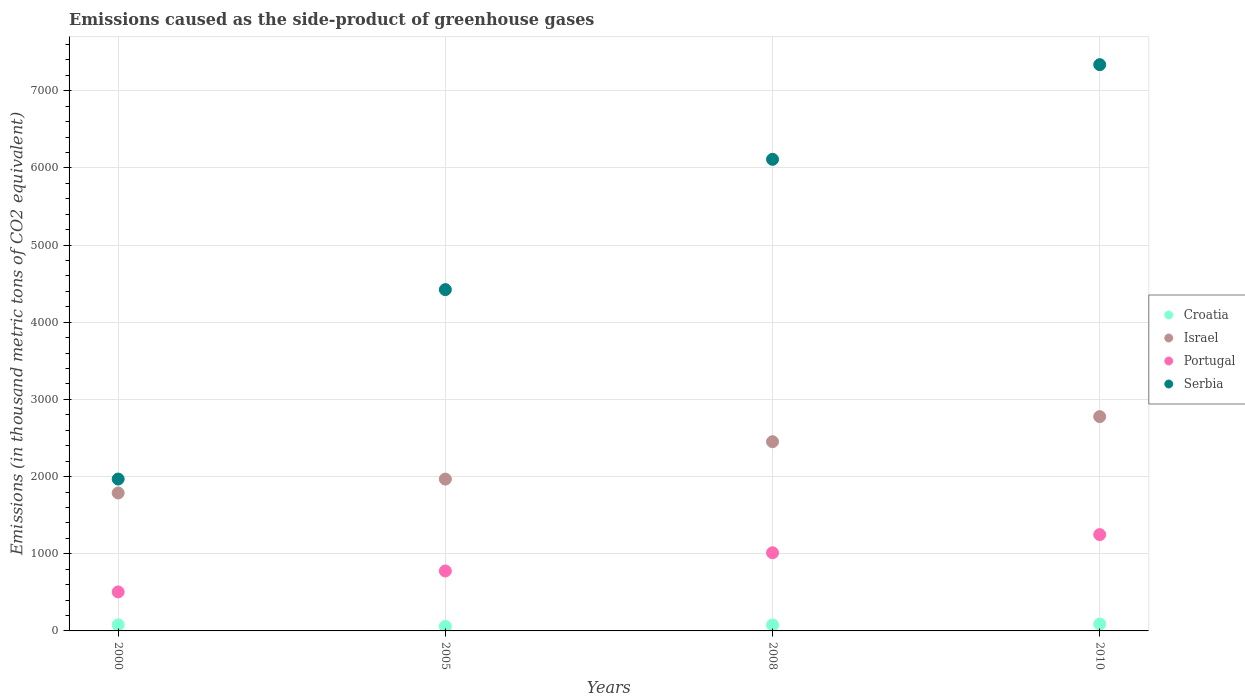How many different coloured dotlines are there?
Your answer should be compact. 4. What is the emissions caused as the side-product of greenhouse gases in Portugal in 2000?
Give a very brief answer. 505.3. Across all years, what is the maximum emissions caused as the side-product of greenhouse gases in Serbia?
Make the answer very short. 7338. Across all years, what is the minimum emissions caused as the side-product of greenhouse gases in Israel?
Your response must be concise. 1787.6. What is the total emissions caused as the side-product of greenhouse gases in Portugal in the graph?
Make the answer very short. 3542.9. What is the difference between the emissions caused as the side-product of greenhouse gases in Serbia in 2000 and that in 2005?
Provide a short and direct response. -2454.7. What is the difference between the emissions caused as the side-product of greenhouse gases in Portugal in 2000 and the emissions caused as the side-product of greenhouse gases in Serbia in 2008?
Your answer should be very brief. -5606. What is the average emissions caused as the side-product of greenhouse gases in Croatia per year?
Provide a succinct answer. 76. In the year 2000, what is the difference between the emissions caused as the side-product of greenhouse gases in Portugal and emissions caused as the side-product of greenhouse gases in Serbia?
Offer a very short reply. -1462.8. What is the ratio of the emissions caused as the side-product of greenhouse gases in Serbia in 2000 to that in 2010?
Give a very brief answer. 0.27. Is the emissions caused as the side-product of greenhouse gases in Croatia in 2008 less than that in 2010?
Your answer should be compact. Yes. What is the difference between the highest and the second highest emissions caused as the side-product of greenhouse gases in Serbia?
Keep it short and to the point. 1226.7. What is the difference between the highest and the lowest emissions caused as the side-product of greenhouse gases in Israel?
Your response must be concise. 989.4. Is it the case that in every year, the sum of the emissions caused as the side-product of greenhouse gases in Croatia and emissions caused as the side-product of greenhouse gases in Israel  is greater than the emissions caused as the side-product of greenhouse gases in Portugal?
Provide a succinct answer. Yes. Does the emissions caused as the side-product of greenhouse gases in Croatia monotonically increase over the years?
Your answer should be compact. No. Is the emissions caused as the side-product of greenhouse gases in Serbia strictly greater than the emissions caused as the side-product of greenhouse gases in Portugal over the years?
Offer a very short reply. Yes. Is the emissions caused as the side-product of greenhouse gases in Serbia strictly less than the emissions caused as the side-product of greenhouse gases in Portugal over the years?
Make the answer very short. No. What is the difference between two consecutive major ticks on the Y-axis?
Keep it short and to the point. 1000. Does the graph contain grids?
Your response must be concise. Yes. How many legend labels are there?
Ensure brevity in your answer.  4. How are the legend labels stacked?
Offer a very short reply. Vertical. What is the title of the graph?
Your response must be concise. Emissions caused as the side-product of greenhouse gases. What is the label or title of the Y-axis?
Keep it short and to the point. Emissions (in thousand metric tons of CO2 equivalent). What is the Emissions (in thousand metric tons of CO2 equivalent) of Croatia in 2000?
Your answer should be very brief. 79.3. What is the Emissions (in thousand metric tons of CO2 equivalent) in Israel in 2000?
Ensure brevity in your answer.  1787.6. What is the Emissions (in thousand metric tons of CO2 equivalent) in Portugal in 2000?
Offer a terse response. 505.3. What is the Emissions (in thousand metric tons of CO2 equivalent) of Serbia in 2000?
Your answer should be very brief. 1968.1. What is the Emissions (in thousand metric tons of CO2 equivalent) in Croatia in 2005?
Give a very brief answer. 58.4. What is the Emissions (in thousand metric tons of CO2 equivalent) of Israel in 2005?
Offer a terse response. 1967.4. What is the Emissions (in thousand metric tons of CO2 equivalent) in Portugal in 2005?
Keep it short and to the point. 776.9. What is the Emissions (in thousand metric tons of CO2 equivalent) of Serbia in 2005?
Your answer should be very brief. 4422.8. What is the Emissions (in thousand metric tons of CO2 equivalent) in Croatia in 2008?
Ensure brevity in your answer.  77.3. What is the Emissions (in thousand metric tons of CO2 equivalent) in Israel in 2008?
Your answer should be very brief. 2452.1. What is the Emissions (in thousand metric tons of CO2 equivalent) in Portugal in 2008?
Ensure brevity in your answer.  1012.7. What is the Emissions (in thousand metric tons of CO2 equivalent) of Serbia in 2008?
Provide a succinct answer. 6111.3. What is the Emissions (in thousand metric tons of CO2 equivalent) in Croatia in 2010?
Your response must be concise. 89. What is the Emissions (in thousand metric tons of CO2 equivalent) of Israel in 2010?
Provide a short and direct response. 2777. What is the Emissions (in thousand metric tons of CO2 equivalent) in Portugal in 2010?
Your answer should be very brief. 1248. What is the Emissions (in thousand metric tons of CO2 equivalent) in Serbia in 2010?
Ensure brevity in your answer.  7338. Across all years, what is the maximum Emissions (in thousand metric tons of CO2 equivalent) of Croatia?
Offer a very short reply. 89. Across all years, what is the maximum Emissions (in thousand metric tons of CO2 equivalent) of Israel?
Ensure brevity in your answer.  2777. Across all years, what is the maximum Emissions (in thousand metric tons of CO2 equivalent) of Portugal?
Make the answer very short. 1248. Across all years, what is the maximum Emissions (in thousand metric tons of CO2 equivalent) of Serbia?
Make the answer very short. 7338. Across all years, what is the minimum Emissions (in thousand metric tons of CO2 equivalent) in Croatia?
Ensure brevity in your answer.  58.4. Across all years, what is the minimum Emissions (in thousand metric tons of CO2 equivalent) of Israel?
Ensure brevity in your answer.  1787.6. Across all years, what is the minimum Emissions (in thousand metric tons of CO2 equivalent) in Portugal?
Provide a succinct answer. 505.3. Across all years, what is the minimum Emissions (in thousand metric tons of CO2 equivalent) in Serbia?
Keep it short and to the point. 1968.1. What is the total Emissions (in thousand metric tons of CO2 equivalent) in Croatia in the graph?
Ensure brevity in your answer.  304. What is the total Emissions (in thousand metric tons of CO2 equivalent) in Israel in the graph?
Your response must be concise. 8984.1. What is the total Emissions (in thousand metric tons of CO2 equivalent) in Portugal in the graph?
Offer a terse response. 3542.9. What is the total Emissions (in thousand metric tons of CO2 equivalent) in Serbia in the graph?
Provide a short and direct response. 1.98e+04. What is the difference between the Emissions (in thousand metric tons of CO2 equivalent) in Croatia in 2000 and that in 2005?
Offer a terse response. 20.9. What is the difference between the Emissions (in thousand metric tons of CO2 equivalent) of Israel in 2000 and that in 2005?
Offer a very short reply. -179.8. What is the difference between the Emissions (in thousand metric tons of CO2 equivalent) of Portugal in 2000 and that in 2005?
Offer a terse response. -271.6. What is the difference between the Emissions (in thousand metric tons of CO2 equivalent) of Serbia in 2000 and that in 2005?
Your response must be concise. -2454.7. What is the difference between the Emissions (in thousand metric tons of CO2 equivalent) in Croatia in 2000 and that in 2008?
Give a very brief answer. 2. What is the difference between the Emissions (in thousand metric tons of CO2 equivalent) in Israel in 2000 and that in 2008?
Provide a succinct answer. -664.5. What is the difference between the Emissions (in thousand metric tons of CO2 equivalent) of Portugal in 2000 and that in 2008?
Offer a very short reply. -507.4. What is the difference between the Emissions (in thousand metric tons of CO2 equivalent) of Serbia in 2000 and that in 2008?
Your answer should be compact. -4143.2. What is the difference between the Emissions (in thousand metric tons of CO2 equivalent) of Israel in 2000 and that in 2010?
Your response must be concise. -989.4. What is the difference between the Emissions (in thousand metric tons of CO2 equivalent) in Portugal in 2000 and that in 2010?
Your answer should be compact. -742.7. What is the difference between the Emissions (in thousand metric tons of CO2 equivalent) in Serbia in 2000 and that in 2010?
Make the answer very short. -5369.9. What is the difference between the Emissions (in thousand metric tons of CO2 equivalent) of Croatia in 2005 and that in 2008?
Provide a succinct answer. -18.9. What is the difference between the Emissions (in thousand metric tons of CO2 equivalent) in Israel in 2005 and that in 2008?
Give a very brief answer. -484.7. What is the difference between the Emissions (in thousand metric tons of CO2 equivalent) in Portugal in 2005 and that in 2008?
Your response must be concise. -235.8. What is the difference between the Emissions (in thousand metric tons of CO2 equivalent) in Serbia in 2005 and that in 2008?
Give a very brief answer. -1688.5. What is the difference between the Emissions (in thousand metric tons of CO2 equivalent) of Croatia in 2005 and that in 2010?
Ensure brevity in your answer.  -30.6. What is the difference between the Emissions (in thousand metric tons of CO2 equivalent) of Israel in 2005 and that in 2010?
Make the answer very short. -809.6. What is the difference between the Emissions (in thousand metric tons of CO2 equivalent) in Portugal in 2005 and that in 2010?
Give a very brief answer. -471.1. What is the difference between the Emissions (in thousand metric tons of CO2 equivalent) in Serbia in 2005 and that in 2010?
Your response must be concise. -2915.2. What is the difference between the Emissions (in thousand metric tons of CO2 equivalent) of Israel in 2008 and that in 2010?
Your answer should be very brief. -324.9. What is the difference between the Emissions (in thousand metric tons of CO2 equivalent) in Portugal in 2008 and that in 2010?
Offer a terse response. -235.3. What is the difference between the Emissions (in thousand metric tons of CO2 equivalent) in Serbia in 2008 and that in 2010?
Provide a succinct answer. -1226.7. What is the difference between the Emissions (in thousand metric tons of CO2 equivalent) of Croatia in 2000 and the Emissions (in thousand metric tons of CO2 equivalent) of Israel in 2005?
Make the answer very short. -1888.1. What is the difference between the Emissions (in thousand metric tons of CO2 equivalent) of Croatia in 2000 and the Emissions (in thousand metric tons of CO2 equivalent) of Portugal in 2005?
Offer a terse response. -697.6. What is the difference between the Emissions (in thousand metric tons of CO2 equivalent) in Croatia in 2000 and the Emissions (in thousand metric tons of CO2 equivalent) in Serbia in 2005?
Make the answer very short. -4343.5. What is the difference between the Emissions (in thousand metric tons of CO2 equivalent) of Israel in 2000 and the Emissions (in thousand metric tons of CO2 equivalent) of Portugal in 2005?
Make the answer very short. 1010.7. What is the difference between the Emissions (in thousand metric tons of CO2 equivalent) in Israel in 2000 and the Emissions (in thousand metric tons of CO2 equivalent) in Serbia in 2005?
Offer a terse response. -2635.2. What is the difference between the Emissions (in thousand metric tons of CO2 equivalent) of Portugal in 2000 and the Emissions (in thousand metric tons of CO2 equivalent) of Serbia in 2005?
Your answer should be very brief. -3917.5. What is the difference between the Emissions (in thousand metric tons of CO2 equivalent) of Croatia in 2000 and the Emissions (in thousand metric tons of CO2 equivalent) of Israel in 2008?
Offer a terse response. -2372.8. What is the difference between the Emissions (in thousand metric tons of CO2 equivalent) in Croatia in 2000 and the Emissions (in thousand metric tons of CO2 equivalent) in Portugal in 2008?
Offer a very short reply. -933.4. What is the difference between the Emissions (in thousand metric tons of CO2 equivalent) in Croatia in 2000 and the Emissions (in thousand metric tons of CO2 equivalent) in Serbia in 2008?
Keep it short and to the point. -6032. What is the difference between the Emissions (in thousand metric tons of CO2 equivalent) of Israel in 2000 and the Emissions (in thousand metric tons of CO2 equivalent) of Portugal in 2008?
Provide a succinct answer. 774.9. What is the difference between the Emissions (in thousand metric tons of CO2 equivalent) in Israel in 2000 and the Emissions (in thousand metric tons of CO2 equivalent) in Serbia in 2008?
Your answer should be compact. -4323.7. What is the difference between the Emissions (in thousand metric tons of CO2 equivalent) in Portugal in 2000 and the Emissions (in thousand metric tons of CO2 equivalent) in Serbia in 2008?
Your answer should be compact. -5606. What is the difference between the Emissions (in thousand metric tons of CO2 equivalent) of Croatia in 2000 and the Emissions (in thousand metric tons of CO2 equivalent) of Israel in 2010?
Ensure brevity in your answer.  -2697.7. What is the difference between the Emissions (in thousand metric tons of CO2 equivalent) of Croatia in 2000 and the Emissions (in thousand metric tons of CO2 equivalent) of Portugal in 2010?
Provide a short and direct response. -1168.7. What is the difference between the Emissions (in thousand metric tons of CO2 equivalent) in Croatia in 2000 and the Emissions (in thousand metric tons of CO2 equivalent) in Serbia in 2010?
Keep it short and to the point. -7258.7. What is the difference between the Emissions (in thousand metric tons of CO2 equivalent) of Israel in 2000 and the Emissions (in thousand metric tons of CO2 equivalent) of Portugal in 2010?
Provide a succinct answer. 539.6. What is the difference between the Emissions (in thousand metric tons of CO2 equivalent) in Israel in 2000 and the Emissions (in thousand metric tons of CO2 equivalent) in Serbia in 2010?
Your response must be concise. -5550.4. What is the difference between the Emissions (in thousand metric tons of CO2 equivalent) of Portugal in 2000 and the Emissions (in thousand metric tons of CO2 equivalent) of Serbia in 2010?
Keep it short and to the point. -6832.7. What is the difference between the Emissions (in thousand metric tons of CO2 equivalent) in Croatia in 2005 and the Emissions (in thousand metric tons of CO2 equivalent) in Israel in 2008?
Your answer should be compact. -2393.7. What is the difference between the Emissions (in thousand metric tons of CO2 equivalent) in Croatia in 2005 and the Emissions (in thousand metric tons of CO2 equivalent) in Portugal in 2008?
Give a very brief answer. -954.3. What is the difference between the Emissions (in thousand metric tons of CO2 equivalent) in Croatia in 2005 and the Emissions (in thousand metric tons of CO2 equivalent) in Serbia in 2008?
Your answer should be compact. -6052.9. What is the difference between the Emissions (in thousand metric tons of CO2 equivalent) in Israel in 2005 and the Emissions (in thousand metric tons of CO2 equivalent) in Portugal in 2008?
Your answer should be very brief. 954.7. What is the difference between the Emissions (in thousand metric tons of CO2 equivalent) in Israel in 2005 and the Emissions (in thousand metric tons of CO2 equivalent) in Serbia in 2008?
Provide a short and direct response. -4143.9. What is the difference between the Emissions (in thousand metric tons of CO2 equivalent) of Portugal in 2005 and the Emissions (in thousand metric tons of CO2 equivalent) of Serbia in 2008?
Give a very brief answer. -5334.4. What is the difference between the Emissions (in thousand metric tons of CO2 equivalent) of Croatia in 2005 and the Emissions (in thousand metric tons of CO2 equivalent) of Israel in 2010?
Offer a very short reply. -2718.6. What is the difference between the Emissions (in thousand metric tons of CO2 equivalent) in Croatia in 2005 and the Emissions (in thousand metric tons of CO2 equivalent) in Portugal in 2010?
Make the answer very short. -1189.6. What is the difference between the Emissions (in thousand metric tons of CO2 equivalent) of Croatia in 2005 and the Emissions (in thousand metric tons of CO2 equivalent) of Serbia in 2010?
Offer a terse response. -7279.6. What is the difference between the Emissions (in thousand metric tons of CO2 equivalent) in Israel in 2005 and the Emissions (in thousand metric tons of CO2 equivalent) in Portugal in 2010?
Your response must be concise. 719.4. What is the difference between the Emissions (in thousand metric tons of CO2 equivalent) of Israel in 2005 and the Emissions (in thousand metric tons of CO2 equivalent) of Serbia in 2010?
Provide a short and direct response. -5370.6. What is the difference between the Emissions (in thousand metric tons of CO2 equivalent) of Portugal in 2005 and the Emissions (in thousand metric tons of CO2 equivalent) of Serbia in 2010?
Offer a terse response. -6561.1. What is the difference between the Emissions (in thousand metric tons of CO2 equivalent) of Croatia in 2008 and the Emissions (in thousand metric tons of CO2 equivalent) of Israel in 2010?
Give a very brief answer. -2699.7. What is the difference between the Emissions (in thousand metric tons of CO2 equivalent) in Croatia in 2008 and the Emissions (in thousand metric tons of CO2 equivalent) in Portugal in 2010?
Give a very brief answer. -1170.7. What is the difference between the Emissions (in thousand metric tons of CO2 equivalent) of Croatia in 2008 and the Emissions (in thousand metric tons of CO2 equivalent) of Serbia in 2010?
Your answer should be compact. -7260.7. What is the difference between the Emissions (in thousand metric tons of CO2 equivalent) of Israel in 2008 and the Emissions (in thousand metric tons of CO2 equivalent) of Portugal in 2010?
Your answer should be compact. 1204.1. What is the difference between the Emissions (in thousand metric tons of CO2 equivalent) in Israel in 2008 and the Emissions (in thousand metric tons of CO2 equivalent) in Serbia in 2010?
Keep it short and to the point. -4885.9. What is the difference between the Emissions (in thousand metric tons of CO2 equivalent) in Portugal in 2008 and the Emissions (in thousand metric tons of CO2 equivalent) in Serbia in 2010?
Offer a terse response. -6325.3. What is the average Emissions (in thousand metric tons of CO2 equivalent) of Israel per year?
Your response must be concise. 2246.03. What is the average Emissions (in thousand metric tons of CO2 equivalent) of Portugal per year?
Your answer should be very brief. 885.73. What is the average Emissions (in thousand metric tons of CO2 equivalent) of Serbia per year?
Your answer should be very brief. 4960.05. In the year 2000, what is the difference between the Emissions (in thousand metric tons of CO2 equivalent) of Croatia and Emissions (in thousand metric tons of CO2 equivalent) of Israel?
Provide a succinct answer. -1708.3. In the year 2000, what is the difference between the Emissions (in thousand metric tons of CO2 equivalent) of Croatia and Emissions (in thousand metric tons of CO2 equivalent) of Portugal?
Offer a terse response. -426. In the year 2000, what is the difference between the Emissions (in thousand metric tons of CO2 equivalent) of Croatia and Emissions (in thousand metric tons of CO2 equivalent) of Serbia?
Your answer should be compact. -1888.8. In the year 2000, what is the difference between the Emissions (in thousand metric tons of CO2 equivalent) in Israel and Emissions (in thousand metric tons of CO2 equivalent) in Portugal?
Your answer should be very brief. 1282.3. In the year 2000, what is the difference between the Emissions (in thousand metric tons of CO2 equivalent) of Israel and Emissions (in thousand metric tons of CO2 equivalent) of Serbia?
Your answer should be compact. -180.5. In the year 2000, what is the difference between the Emissions (in thousand metric tons of CO2 equivalent) of Portugal and Emissions (in thousand metric tons of CO2 equivalent) of Serbia?
Offer a very short reply. -1462.8. In the year 2005, what is the difference between the Emissions (in thousand metric tons of CO2 equivalent) in Croatia and Emissions (in thousand metric tons of CO2 equivalent) in Israel?
Keep it short and to the point. -1909. In the year 2005, what is the difference between the Emissions (in thousand metric tons of CO2 equivalent) in Croatia and Emissions (in thousand metric tons of CO2 equivalent) in Portugal?
Your answer should be compact. -718.5. In the year 2005, what is the difference between the Emissions (in thousand metric tons of CO2 equivalent) of Croatia and Emissions (in thousand metric tons of CO2 equivalent) of Serbia?
Offer a very short reply. -4364.4. In the year 2005, what is the difference between the Emissions (in thousand metric tons of CO2 equivalent) of Israel and Emissions (in thousand metric tons of CO2 equivalent) of Portugal?
Your answer should be compact. 1190.5. In the year 2005, what is the difference between the Emissions (in thousand metric tons of CO2 equivalent) in Israel and Emissions (in thousand metric tons of CO2 equivalent) in Serbia?
Give a very brief answer. -2455.4. In the year 2005, what is the difference between the Emissions (in thousand metric tons of CO2 equivalent) of Portugal and Emissions (in thousand metric tons of CO2 equivalent) of Serbia?
Provide a succinct answer. -3645.9. In the year 2008, what is the difference between the Emissions (in thousand metric tons of CO2 equivalent) in Croatia and Emissions (in thousand metric tons of CO2 equivalent) in Israel?
Offer a very short reply. -2374.8. In the year 2008, what is the difference between the Emissions (in thousand metric tons of CO2 equivalent) of Croatia and Emissions (in thousand metric tons of CO2 equivalent) of Portugal?
Keep it short and to the point. -935.4. In the year 2008, what is the difference between the Emissions (in thousand metric tons of CO2 equivalent) in Croatia and Emissions (in thousand metric tons of CO2 equivalent) in Serbia?
Your answer should be compact. -6034. In the year 2008, what is the difference between the Emissions (in thousand metric tons of CO2 equivalent) of Israel and Emissions (in thousand metric tons of CO2 equivalent) of Portugal?
Your answer should be very brief. 1439.4. In the year 2008, what is the difference between the Emissions (in thousand metric tons of CO2 equivalent) in Israel and Emissions (in thousand metric tons of CO2 equivalent) in Serbia?
Your answer should be compact. -3659.2. In the year 2008, what is the difference between the Emissions (in thousand metric tons of CO2 equivalent) of Portugal and Emissions (in thousand metric tons of CO2 equivalent) of Serbia?
Give a very brief answer. -5098.6. In the year 2010, what is the difference between the Emissions (in thousand metric tons of CO2 equivalent) of Croatia and Emissions (in thousand metric tons of CO2 equivalent) of Israel?
Your answer should be compact. -2688. In the year 2010, what is the difference between the Emissions (in thousand metric tons of CO2 equivalent) in Croatia and Emissions (in thousand metric tons of CO2 equivalent) in Portugal?
Keep it short and to the point. -1159. In the year 2010, what is the difference between the Emissions (in thousand metric tons of CO2 equivalent) of Croatia and Emissions (in thousand metric tons of CO2 equivalent) of Serbia?
Your response must be concise. -7249. In the year 2010, what is the difference between the Emissions (in thousand metric tons of CO2 equivalent) of Israel and Emissions (in thousand metric tons of CO2 equivalent) of Portugal?
Provide a short and direct response. 1529. In the year 2010, what is the difference between the Emissions (in thousand metric tons of CO2 equivalent) of Israel and Emissions (in thousand metric tons of CO2 equivalent) of Serbia?
Keep it short and to the point. -4561. In the year 2010, what is the difference between the Emissions (in thousand metric tons of CO2 equivalent) of Portugal and Emissions (in thousand metric tons of CO2 equivalent) of Serbia?
Give a very brief answer. -6090. What is the ratio of the Emissions (in thousand metric tons of CO2 equivalent) in Croatia in 2000 to that in 2005?
Offer a very short reply. 1.36. What is the ratio of the Emissions (in thousand metric tons of CO2 equivalent) of Israel in 2000 to that in 2005?
Give a very brief answer. 0.91. What is the ratio of the Emissions (in thousand metric tons of CO2 equivalent) of Portugal in 2000 to that in 2005?
Your answer should be compact. 0.65. What is the ratio of the Emissions (in thousand metric tons of CO2 equivalent) of Serbia in 2000 to that in 2005?
Your answer should be very brief. 0.45. What is the ratio of the Emissions (in thousand metric tons of CO2 equivalent) of Croatia in 2000 to that in 2008?
Your answer should be compact. 1.03. What is the ratio of the Emissions (in thousand metric tons of CO2 equivalent) of Israel in 2000 to that in 2008?
Ensure brevity in your answer.  0.73. What is the ratio of the Emissions (in thousand metric tons of CO2 equivalent) of Portugal in 2000 to that in 2008?
Provide a short and direct response. 0.5. What is the ratio of the Emissions (in thousand metric tons of CO2 equivalent) of Serbia in 2000 to that in 2008?
Offer a terse response. 0.32. What is the ratio of the Emissions (in thousand metric tons of CO2 equivalent) in Croatia in 2000 to that in 2010?
Your answer should be very brief. 0.89. What is the ratio of the Emissions (in thousand metric tons of CO2 equivalent) of Israel in 2000 to that in 2010?
Offer a terse response. 0.64. What is the ratio of the Emissions (in thousand metric tons of CO2 equivalent) of Portugal in 2000 to that in 2010?
Offer a very short reply. 0.4. What is the ratio of the Emissions (in thousand metric tons of CO2 equivalent) of Serbia in 2000 to that in 2010?
Your answer should be compact. 0.27. What is the ratio of the Emissions (in thousand metric tons of CO2 equivalent) in Croatia in 2005 to that in 2008?
Provide a succinct answer. 0.76. What is the ratio of the Emissions (in thousand metric tons of CO2 equivalent) in Israel in 2005 to that in 2008?
Offer a terse response. 0.8. What is the ratio of the Emissions (in thousand metric tons of CO2 equivalent) of Portugal in 2005 to that in 2008?
Make the answer very short. 0.77. What is the ratio of the Emissions (in thousand metric tons of CO2 equivalent) of Serbia in 2005 to that in 2008?
Your answer should be very brief. 0.72. What is the ratio of the Emissions (in thousand metric tons of CO2 equivalent) in Croatia in 2005 to that in 2010?
Keep it short and to the point. 0.66. What is the ratio of the Emissions (in thousand metric tons of CO2 equivalent) of Israel in 2005 to that in 2010?
Ensure brevity in your answer.  0.71. What is the ratio of the Emissions (in thousand metric tons of CO2 equivalent) of Portugal in 2005 to that in 2010?
Your response must be concise. 0.62. What is the ratio of the Emissions (in thousand metric tons of CO2 equivalent) of Serbia in 2005 to that in 2010?
Your response must be concise. 0.6. What is the ratio of the Emissions (in thousand metric tons of CO2 equivalent) in Croatia in 2008 to that in 2010?
Your answer should be compact. 0.87. What is the ratio of the Emissions (in thousand metric tons of CO2 equivalent) in Israel in 2008 to that in 2010?
Provide a short and direct response. 0.88. What is the ratio of the Emissions (in thousand metric tons of CO2 equivalent) in Portugal in 2008 to that in 2010?
Give a very brief answer. 0.81. What is the ratio of the Emissions (in thousand metric tons of CO2 equivalent) in Serbia in 2008 to that in 2010?
Offer a terse response. 0.83. What is the difference between the highest and the second highest Emissions (in thousand metric tons of CO2 equivalent) of Israel?
Make the answer very short. 324.9. What is the difference between the highest and the second highest Emissions (in thousand metric tons of CO2 equivalent) of Portugal?
Your answer should be compact. 235.3. What is the difference between the highest and the second highest Emissions (in thousand metric tons of CO2 equivalent) in Serbia?
Make the answer very short. 1226.7. What is the difference between the highest and the lowest Emissions (in thousand metric tons of CO2 equivalent) in Croatia?
Ensure brevity in your answer.  30.6. What is the difference between the highest and the lowest Emissions (in thousand metric tons of CO2 equivalent) of Israel?
Your response must be concise. 989.4. What is the difference between the highest and the lowest Emissions (in thousand metric tons of CO2 equivalent) of Portugal?
Ensure brevity in your answer.  742.7. What is the difference between the highest and the lowest Emissions (in thousand metric tons of CO2 equivalent) of Serbia?
Keep it short and to the point. 5369.9. 